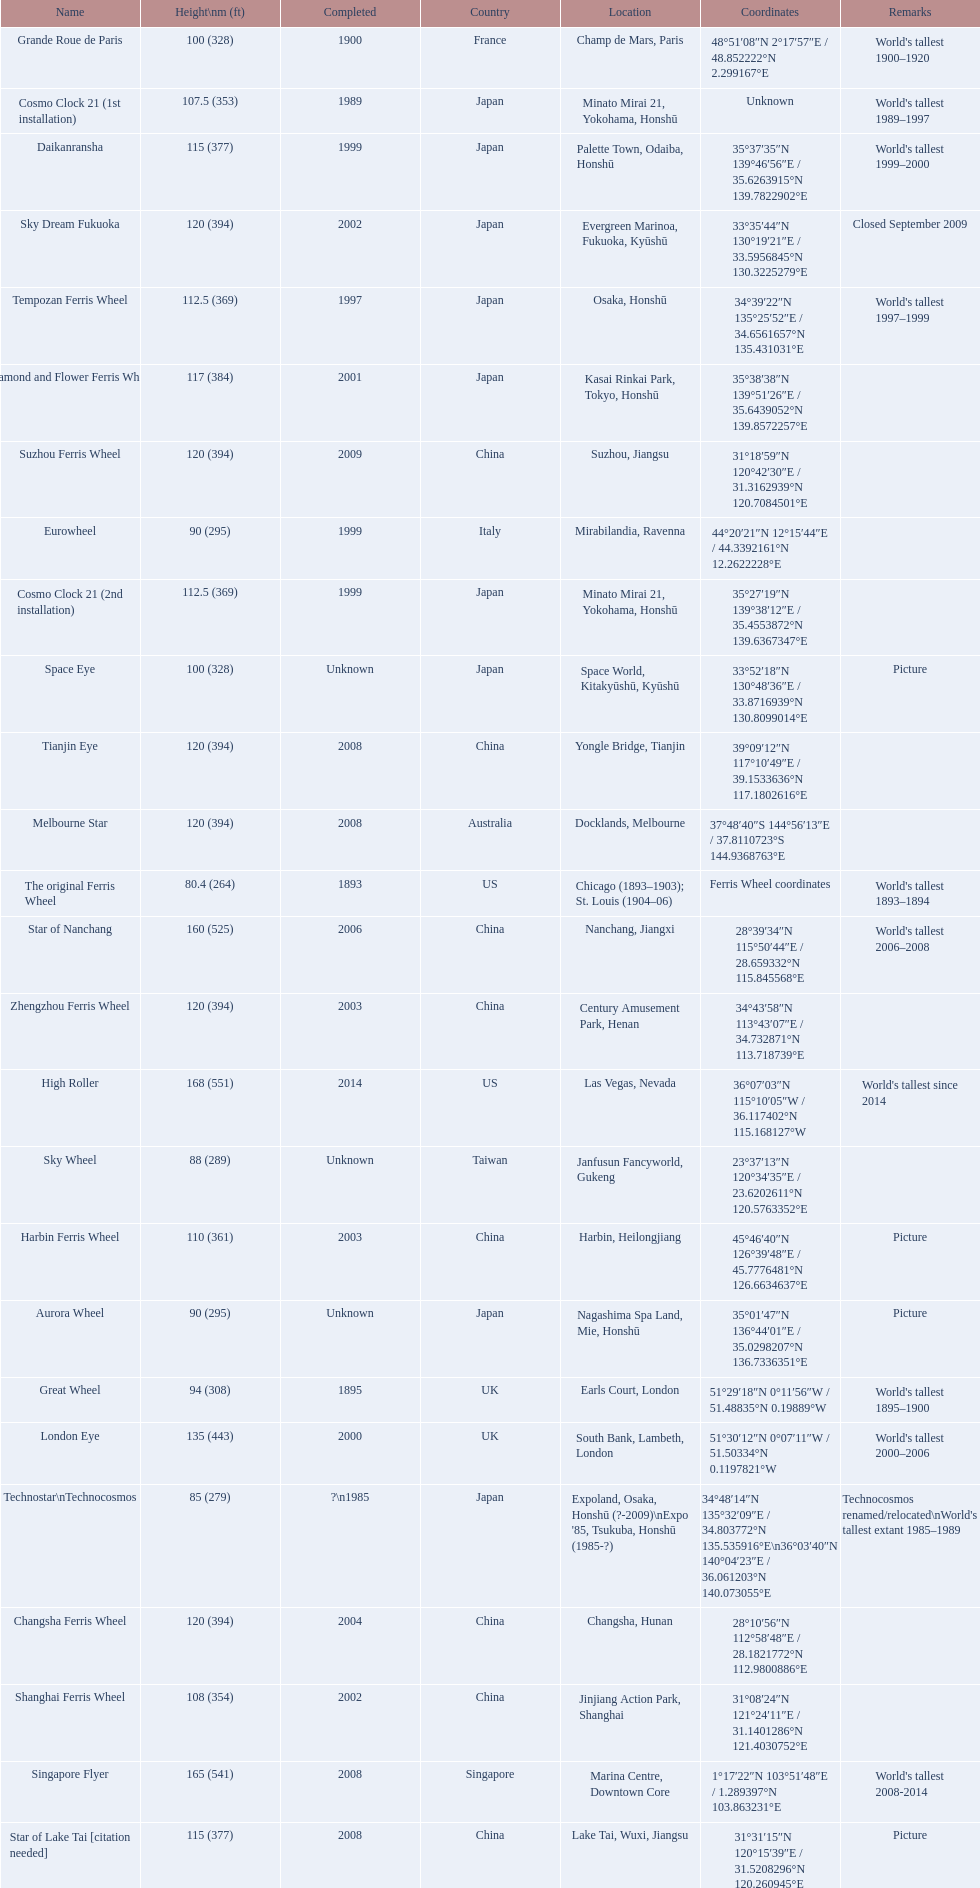What ferris wheels were completed in 2008 Singapore Flyer, Melbourne Star, Tianjin Eye, Star of Lake Tai [citation needed]. Of these, which has the height of 165? Singapore Flyer. 